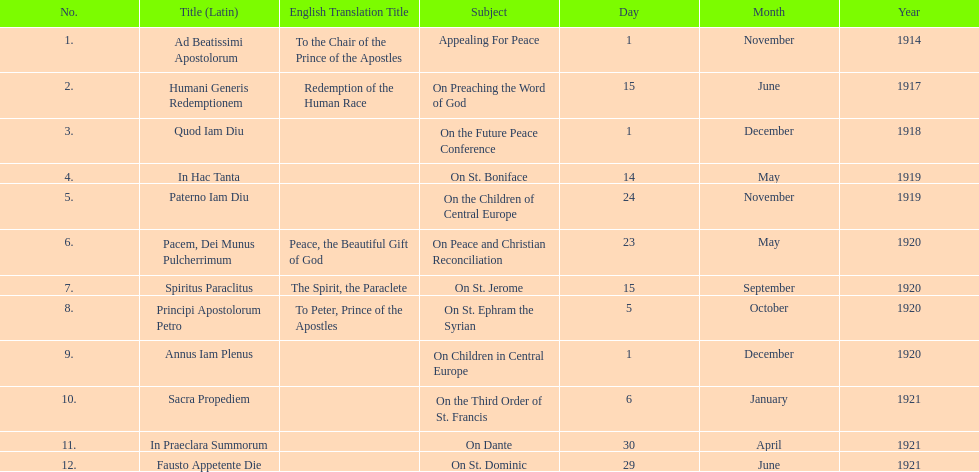Other than january how many encyclicals were in 1921? 2. 